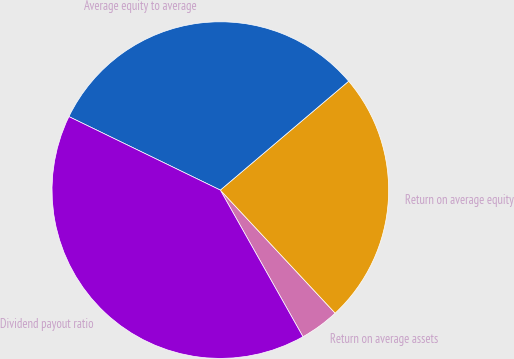Convert chart to OTSL. <chart><loc_0><loc_0><loc_500><loc_500><pie_chart><fcel>Return on average assets<fcel>Return on average equity<fcel>Average equity to average<fcel>Dividend payout ratio<nl><fcel>3.78%<fcel>24.25%<fcel>31.61%<fcel>40.36%<nl></chart> 